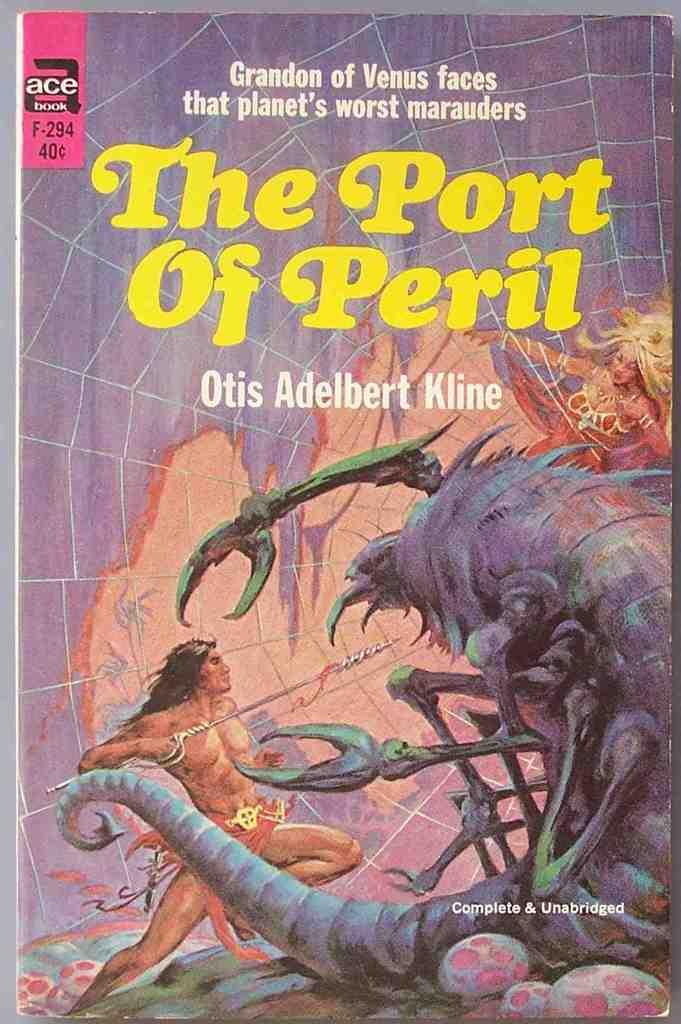<image>
Render a clear and concise summary of the photo. A science fiction book entitled "The Port of Peril". 